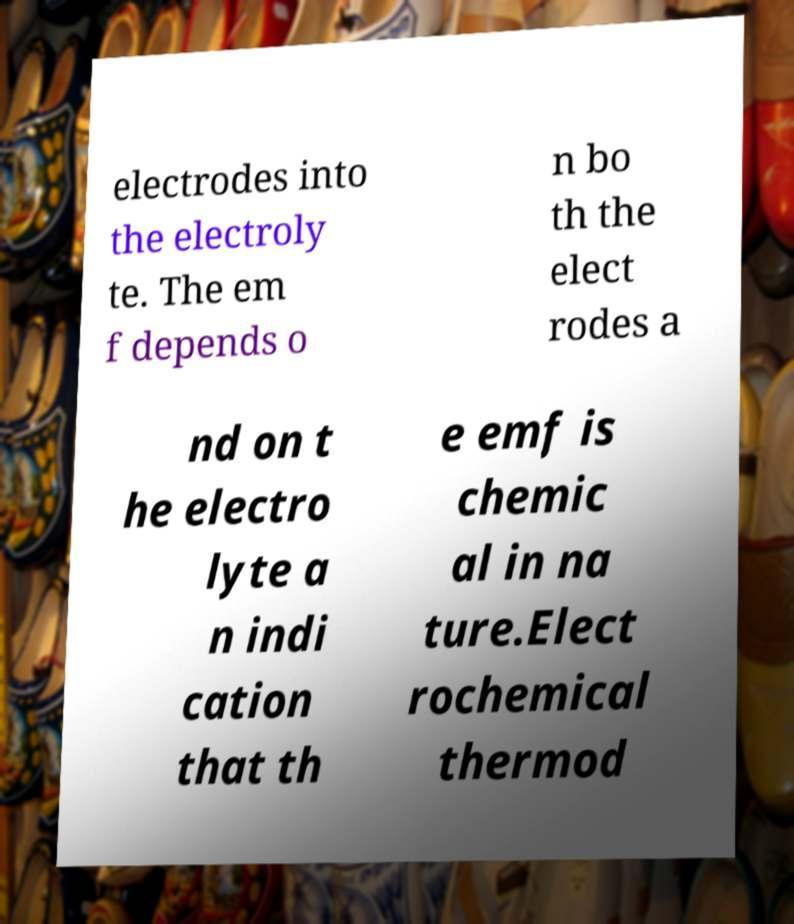I need the written content from this picture converted into text. Can you do that? electrodes into the electroly te. The em f depends o n bo th the elect rodes a nd on t he electro lyte a n indi cation that th e emf is chemic al in na ture.Elect rochemical thermod 